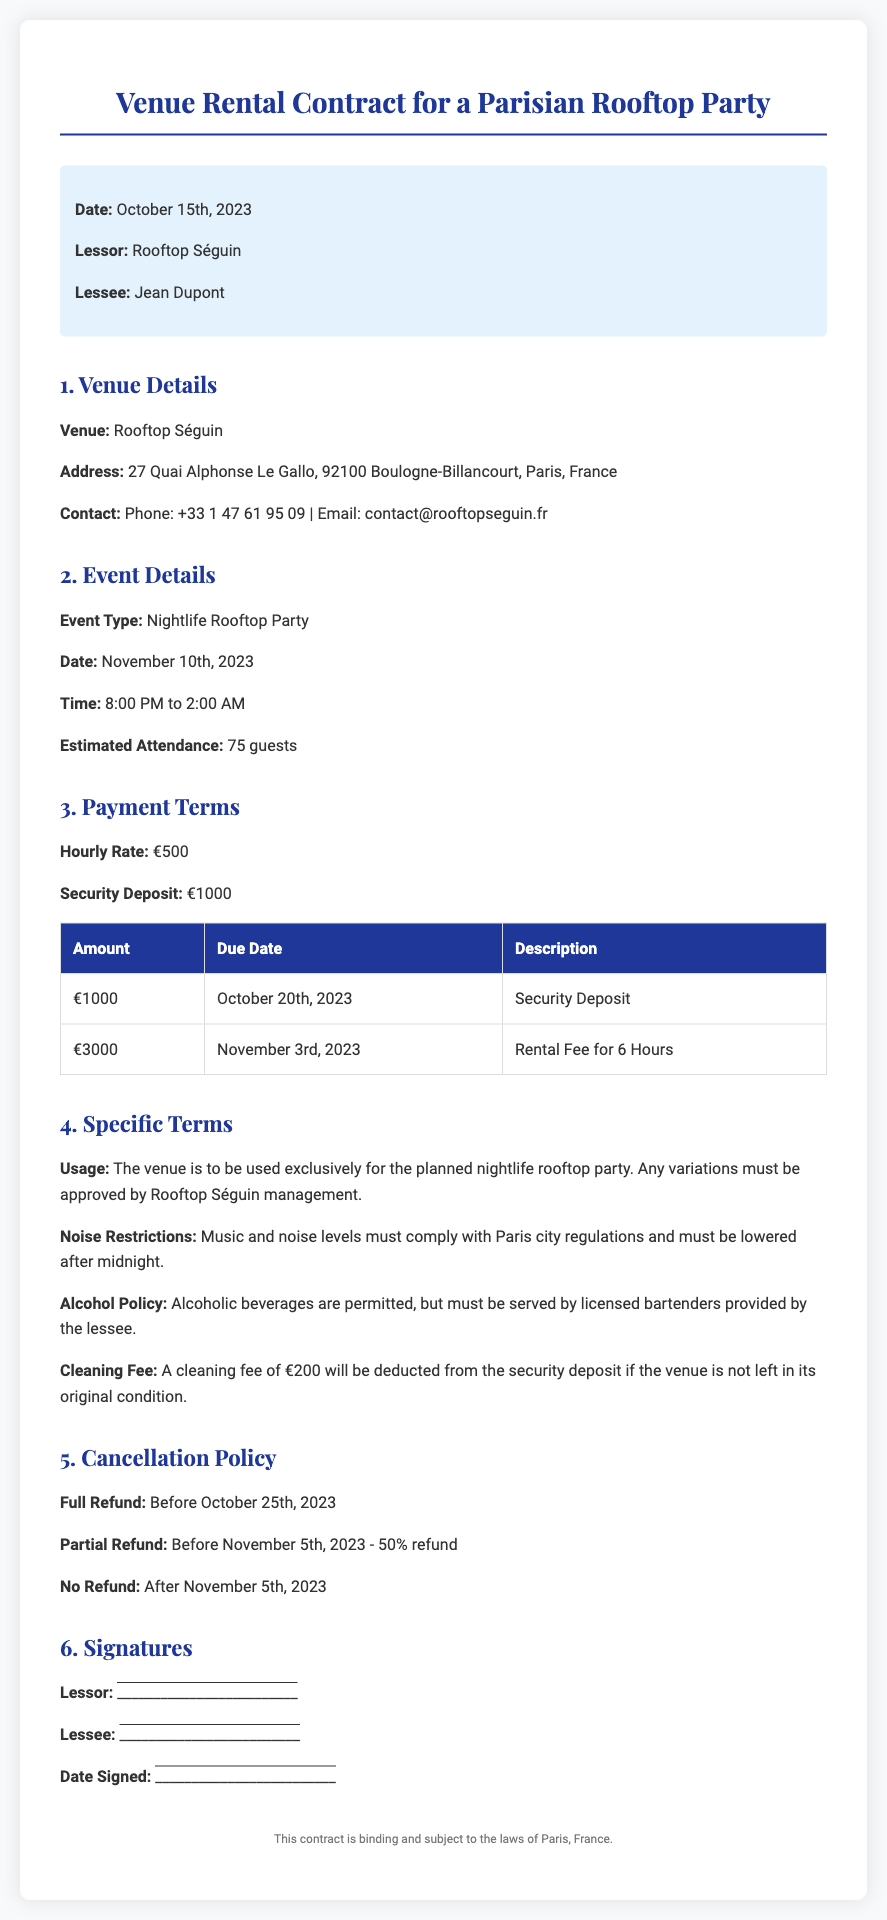What is the date of the event? The date of the event is explicitly stated in the document under Event Details.
Answer: November 10th, 2023 Who is the lessee? The lessee's name is provided in the highlight section at the beginning of the document.
Answer: Jean Dupont What is the hourly rate for the venue rental? The hourly rate can be found in the Payment Terms section of the document.
Answer: €500 What is the total amount due for the rental fee? The total rental fee is given in the Payment Terms table under the description 'Rental Fee for 6 Hours.'
Answer: €3000 What is the cancellation policy for a full refund? The cancellation policy is specified in the Cancellation Policy section, indicating the date for a full refund.
Answer: Before October 25th, 2023 What is the cleaning fee if the venue is not left in original condition? The cleaning fee is stated in the Specific Terms section of the document.
Answer: €200 Which policy states that alcohol must be served by licensed bartenders? The specific term related to alcohol service is detailed in the Specific Terms section.
Answer: Alcohol Policy When is the security deposit due? The due date for the security deposit is mentioned in the Payment Terms table.
Answer: October 20th, 2023 